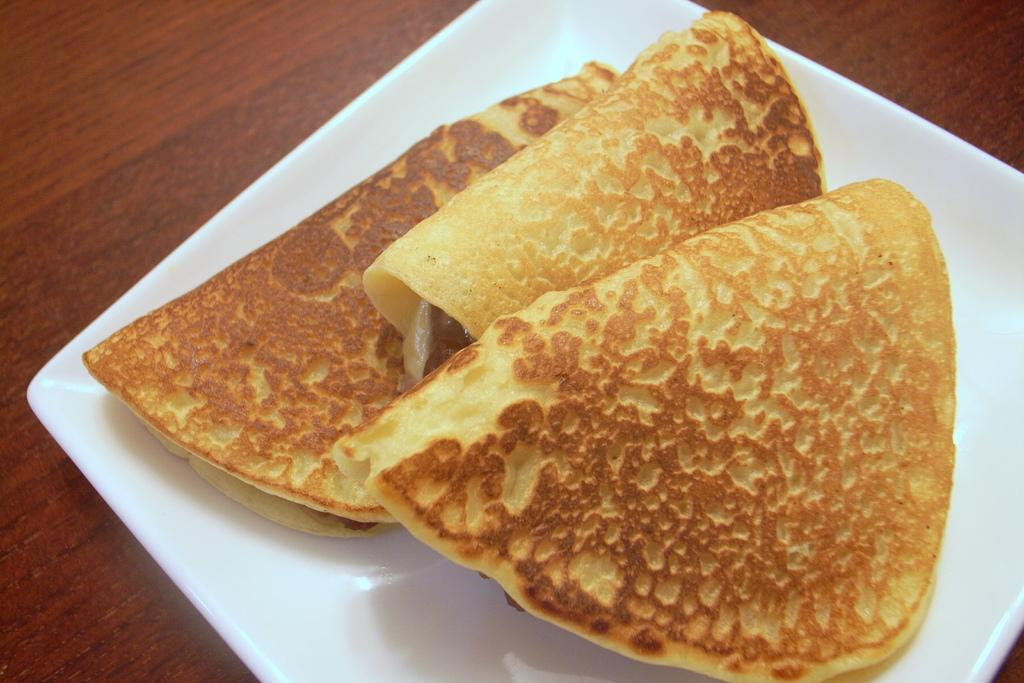What is the color of the plate or tray in the image? The plate or tray in the image is white. What is on the plate or tray? The plate or tray contains eatables. What is the color of the table in the image? The table is brown. What type of design can be seen on the coal in the image? There is no coal present in the image, so it is not possible to answer that question. 